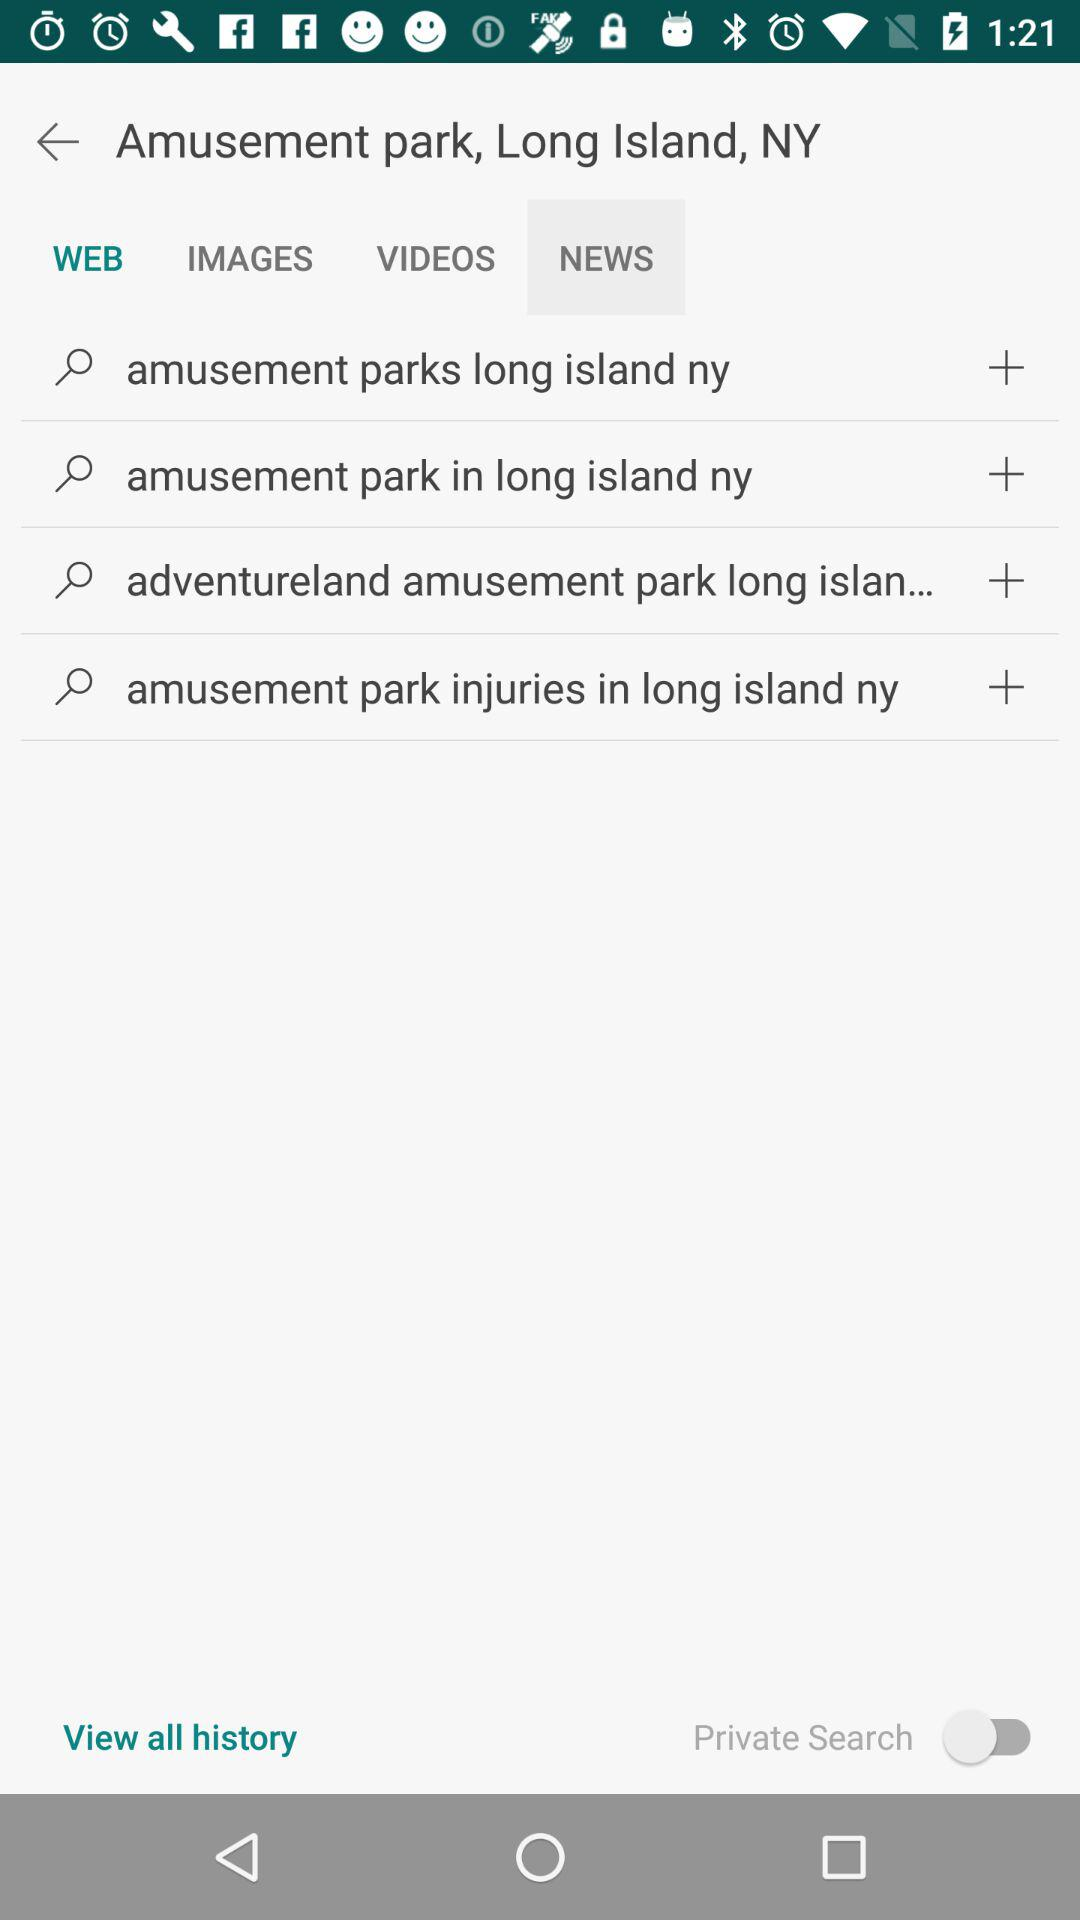How many search results are there?
Answer the question using a single word or phrase. 4 